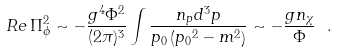Convert formula to latex. <formula><loc_0><loc_0><loc_500><loc_500>R e \, \Pi _ { \phi } ^ { 2 } \sim - { \frac { g ^ { 4 } \Phi ^ { 2 } } { ( 2 \pi ) ^ { 3 } } } \int { \frac { n _ { p } d ^ { 3 } p } { p _ { 0 } \left ( { p _ { 0 } } ^ { 2 } - m ^ { 2 } \right ) } } \sim - { \frac { g n _ { \chi } } { \Phi } } \ .</formula> 